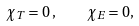Convert formula to latex. <formula><loc_0><loc_0><loc_500><loc_500>\chi _ { T } = 0 \, , \quad \chi _ { E } = 0 ,</formula> 